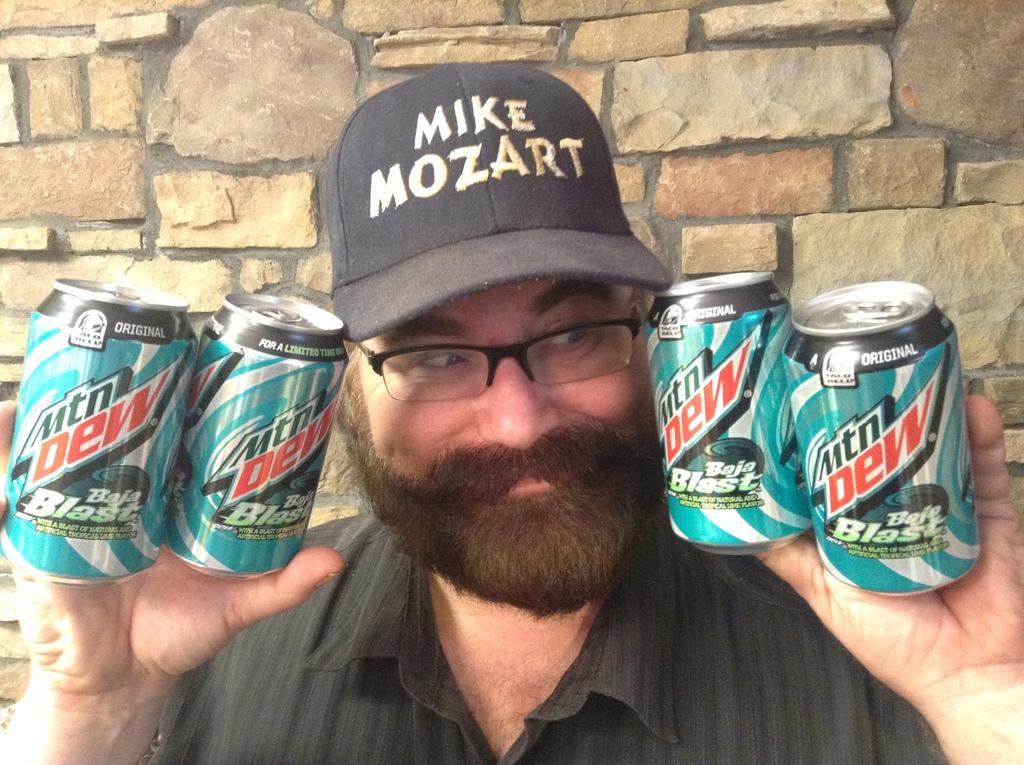Are these mountain dews?
Provide a succinct answer. Yes. What is name is on the man's hat?
Your answer should be compact. Mike mozart. 